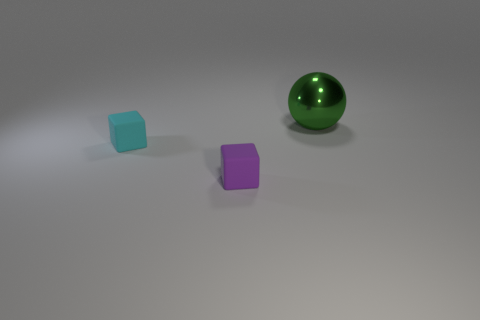Add 1 small shiny cylinders. How many objects exist? 4 Subtract all small rubber objects. Subtract all big green spheres. How many objects are left? 0 Add 1 metal spheres. How many metal spheres are left? 2 Add 1 purple matte cubes. How many purple matte cubes exist? 2 Subtract 0 red spheres. How many objects are left? 3 Subtract all cubes. How many objects are left? 1 